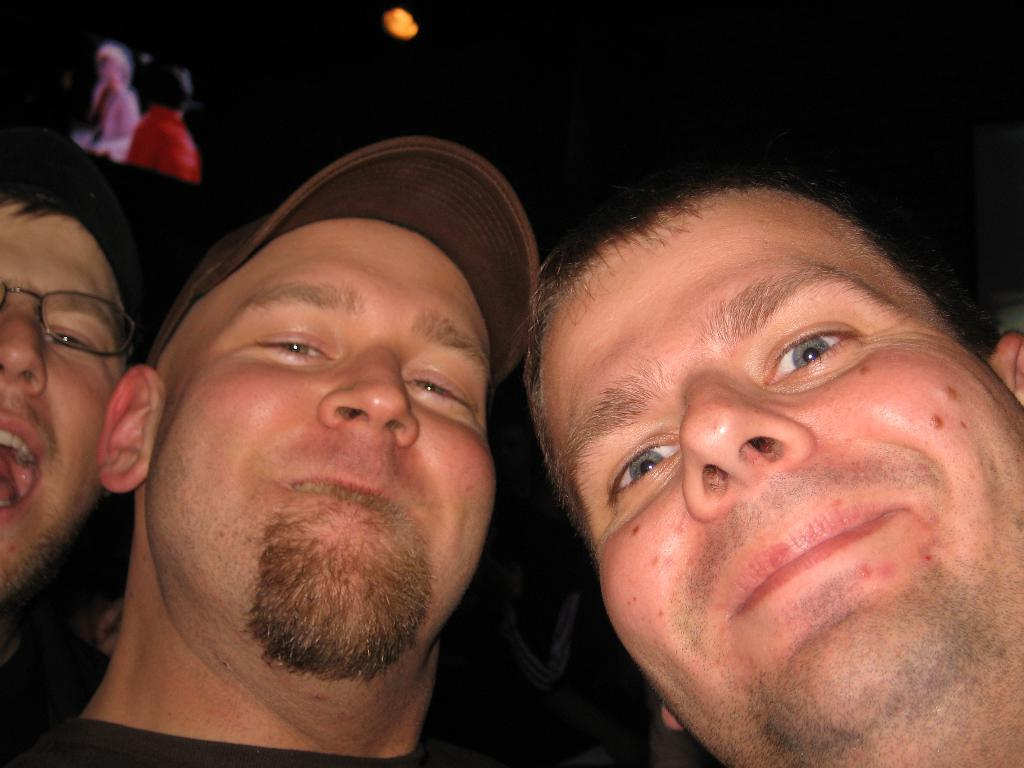How many people are in the image? There are three men in the image. What are the men doing in the image? The men are beside each other and smiling. What can be seen on the left side of the image? There is a screen on the left side of the image. What is the source of light in the image? There is a light over the ceiling in the image. What type of yarn is the man on the right holding in the image? There is no yarn present in the image; the men are simply standing beside each other and smiling. 